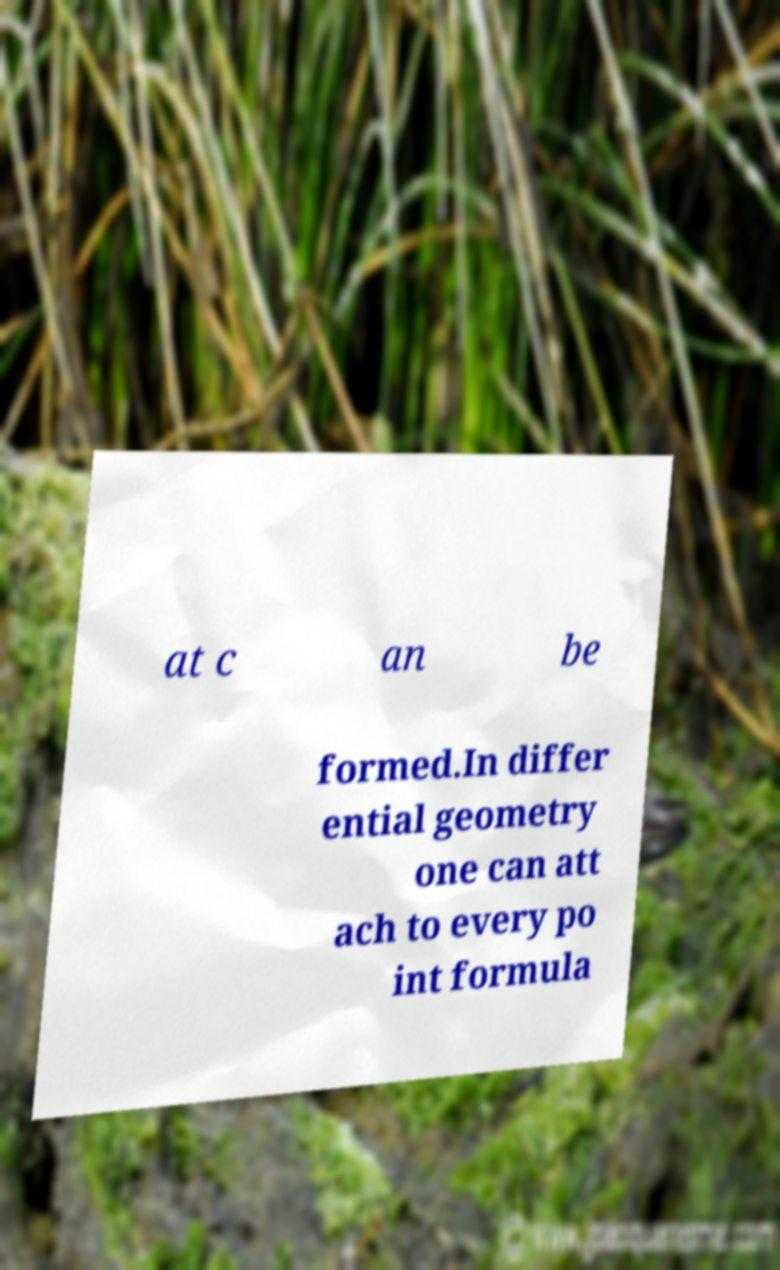Can you read and provide the text displayed in the image?This photo seems to have some interesting text. Can you extract and type it out for me? at c an be formed.In differ ential geometry one can att ach to every po int formula 